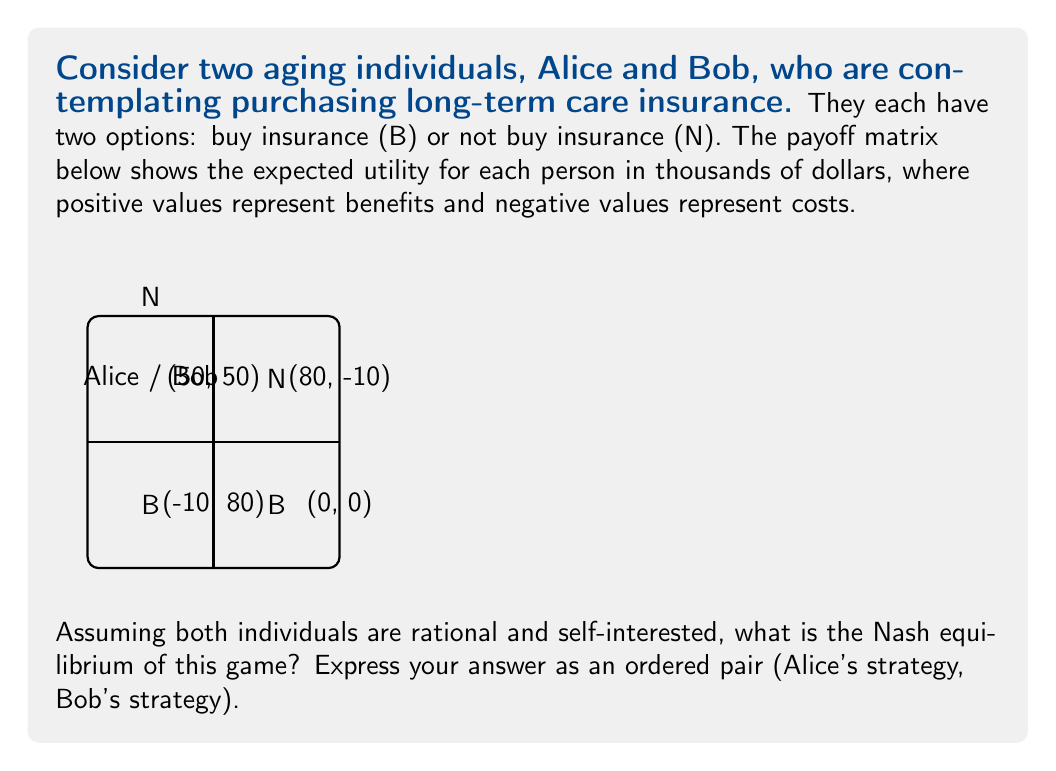Can you solve this math problem? To find the Nash equilibrium, we need to determine the best response for each player given the other player's strategy. Let's analyze this step-by-step:

1) First, consider Alice's perspective:
   - If Bob chooses B, Alice's best response is N (80 > 50)
   - If Bob chooses N, Alice's best response is B (-10 > 0)

2) Now, consider Bob's perspective:
   - If Alice chooses B, Bob's best response is N (80 > 50)
   - If Alice chooses N, Bob's best response is B (-10 > 0)

3) A Nash equilibrium occurs when neither player can unilaterally improve their outcome by changing their strategy.

4) Looking at the payoff matrix, we can see that:
   - (B, B) is not stable because both players would prefer to switch to N
   - (B, N) is not stable because Alice would prefer to switch to N
   - (N, B) is not stable because Bob would prefer to switch to N
   - (N, N) is not stable because both players would prefer to switch to B

5) Since there's no pure strategy Nash equilibrium, we need to consider mixed strategies.

6) Let $p$ be the probability that Alice chooses B, and $q$ be the probability that Bob chooses B.

7) For Alice to be indifferent between B and N:
   $50q + (-10)(1-q) = 80q + 0(1-q)$
   $60q - 10 = 80q$
   $-10 = 20q$
   $q = 1/2$

8) Similarly, for Bob to be indifferent:
   $50p + (-10)(1-p) = 80p + 0(1-p)$
   $60p - 10 = 80p$
   $-10 = 20p$
   $p = 1/2$

9) Therefore, the mixed strategy Nash equilibrium is where both Alice and Bob choose B with probability 1/2 and N with probability 1/2.
Answer: (1/2B + 1/2N, 1/2B + 1/2N) 